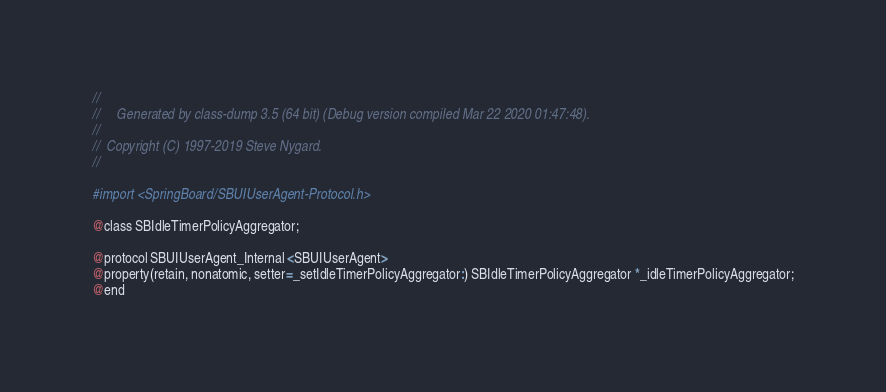Convert code to text. <code><loc_0><loc_0><loc_500><loc_500><_C_>//
//     Generated by class-dump 3.5 (64 bit) (Debug version compiled Mar 22 2020 01:47:48).
//
//  Copyright (C) 1997-2019 Steve Nygard.
//

#import <SpringBoard/SBUIUserAgent-Protocol.h>

@class SBIdleTimerPolicyAggregator;

@protocol SBUIUserAgent_Internal <SBUIUserAgent>
@property(retain, nonatomic, setter=_setIdleTimerPolicyAggregator:) SBIdleTimerPolicyAggregator *_idleTimerPolicyAggregator;
@end

</code> 